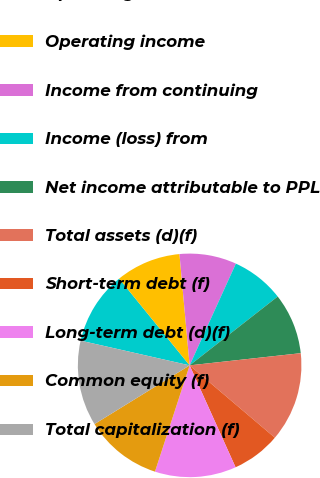Convert chart to OTSL. <chart><loc_0><loc_0><loc_500><loc_500><pie_chart><fcel>Operating revenues<fcel>Operating income<fcel>Income from continuing<fcel>Income (loss) from<fcel>Net income attributable to PPL<fcel>Total assets (d)(f)<fcel>Short-term debt (f)<fcel>Long-term debt (d)(f)<fcel>Common equity (f)<fcel>Total capitalization (f)<nl><fcel>10.59%<fcel>9.41%<fcel>8.24%<fcel>7.65%<fcel>8.82%<fcel>12.94%<fcel>7.06%<fcel>11.76%<fcel>11.18%<fcel>12.35%<nl></chart> 